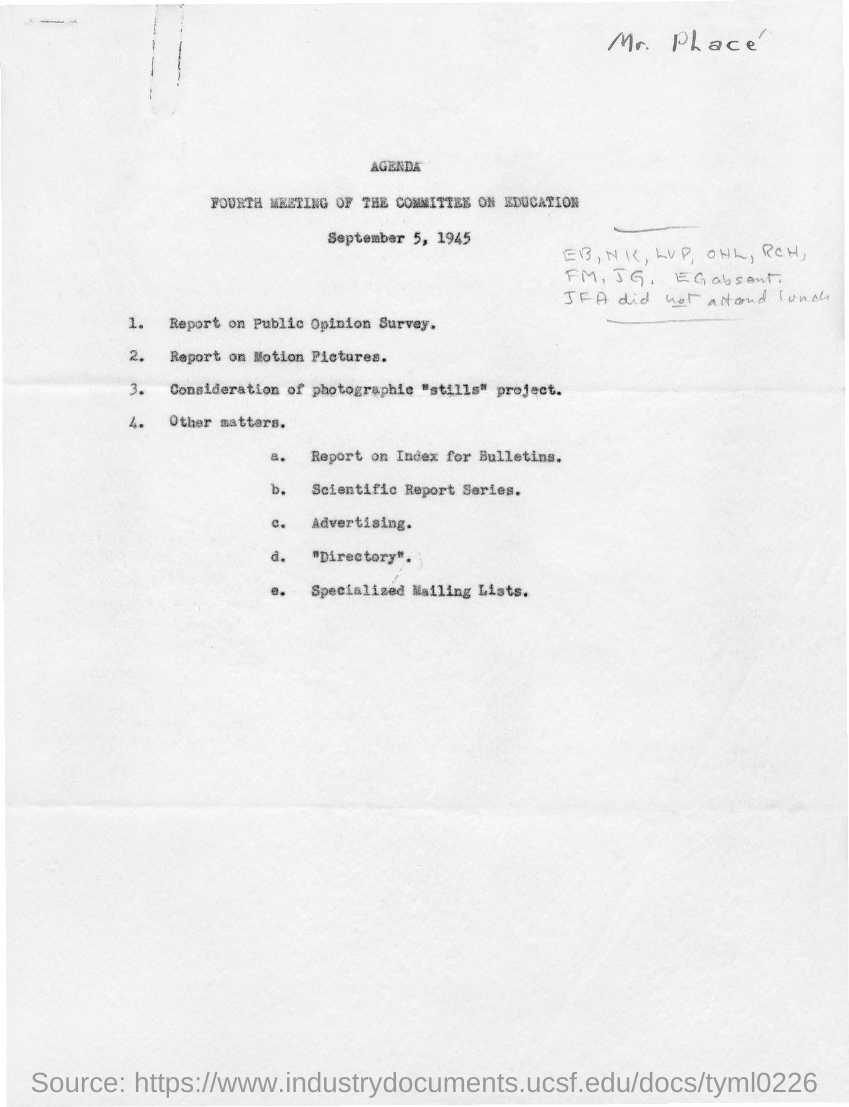When is the fourth meeting of the committee on education held?
Your response must be concise. September 5, 1945. 